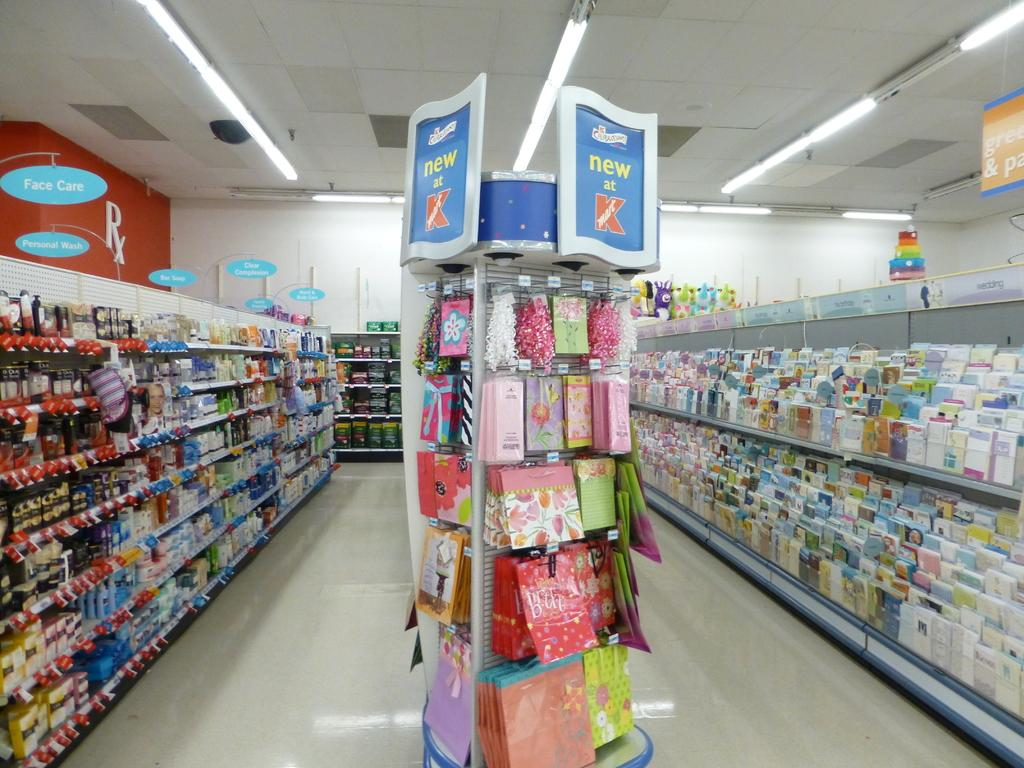<image>
Summarize the visual content of the image. Kmart store with items of greeting cards and other items on the left. 